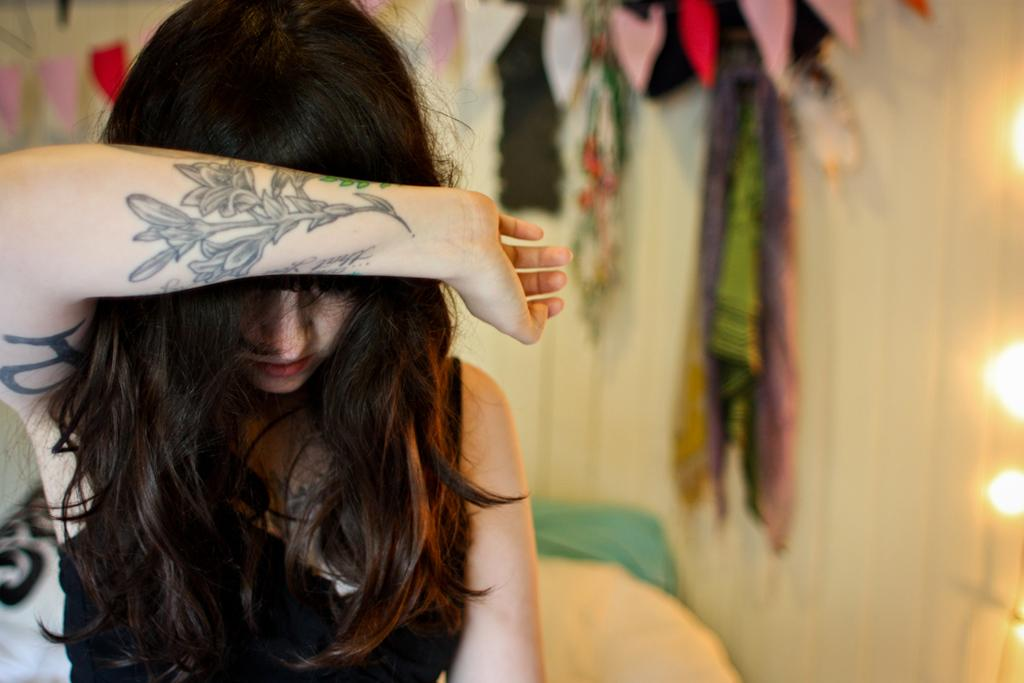Who is present in the image? There is a woman in the image. What is located at the bottom of the image? There is a bed at the bottom of the image. What can be seen in the background of the image? There is a wall in the background of the image. What type of illumination is present in the image? There are lights in the image. What else can be seen in the image besides the woman and the bed? There are clothes in the image. Can you see any boats in the yard in the image? There is no yard or boats present in the image. 